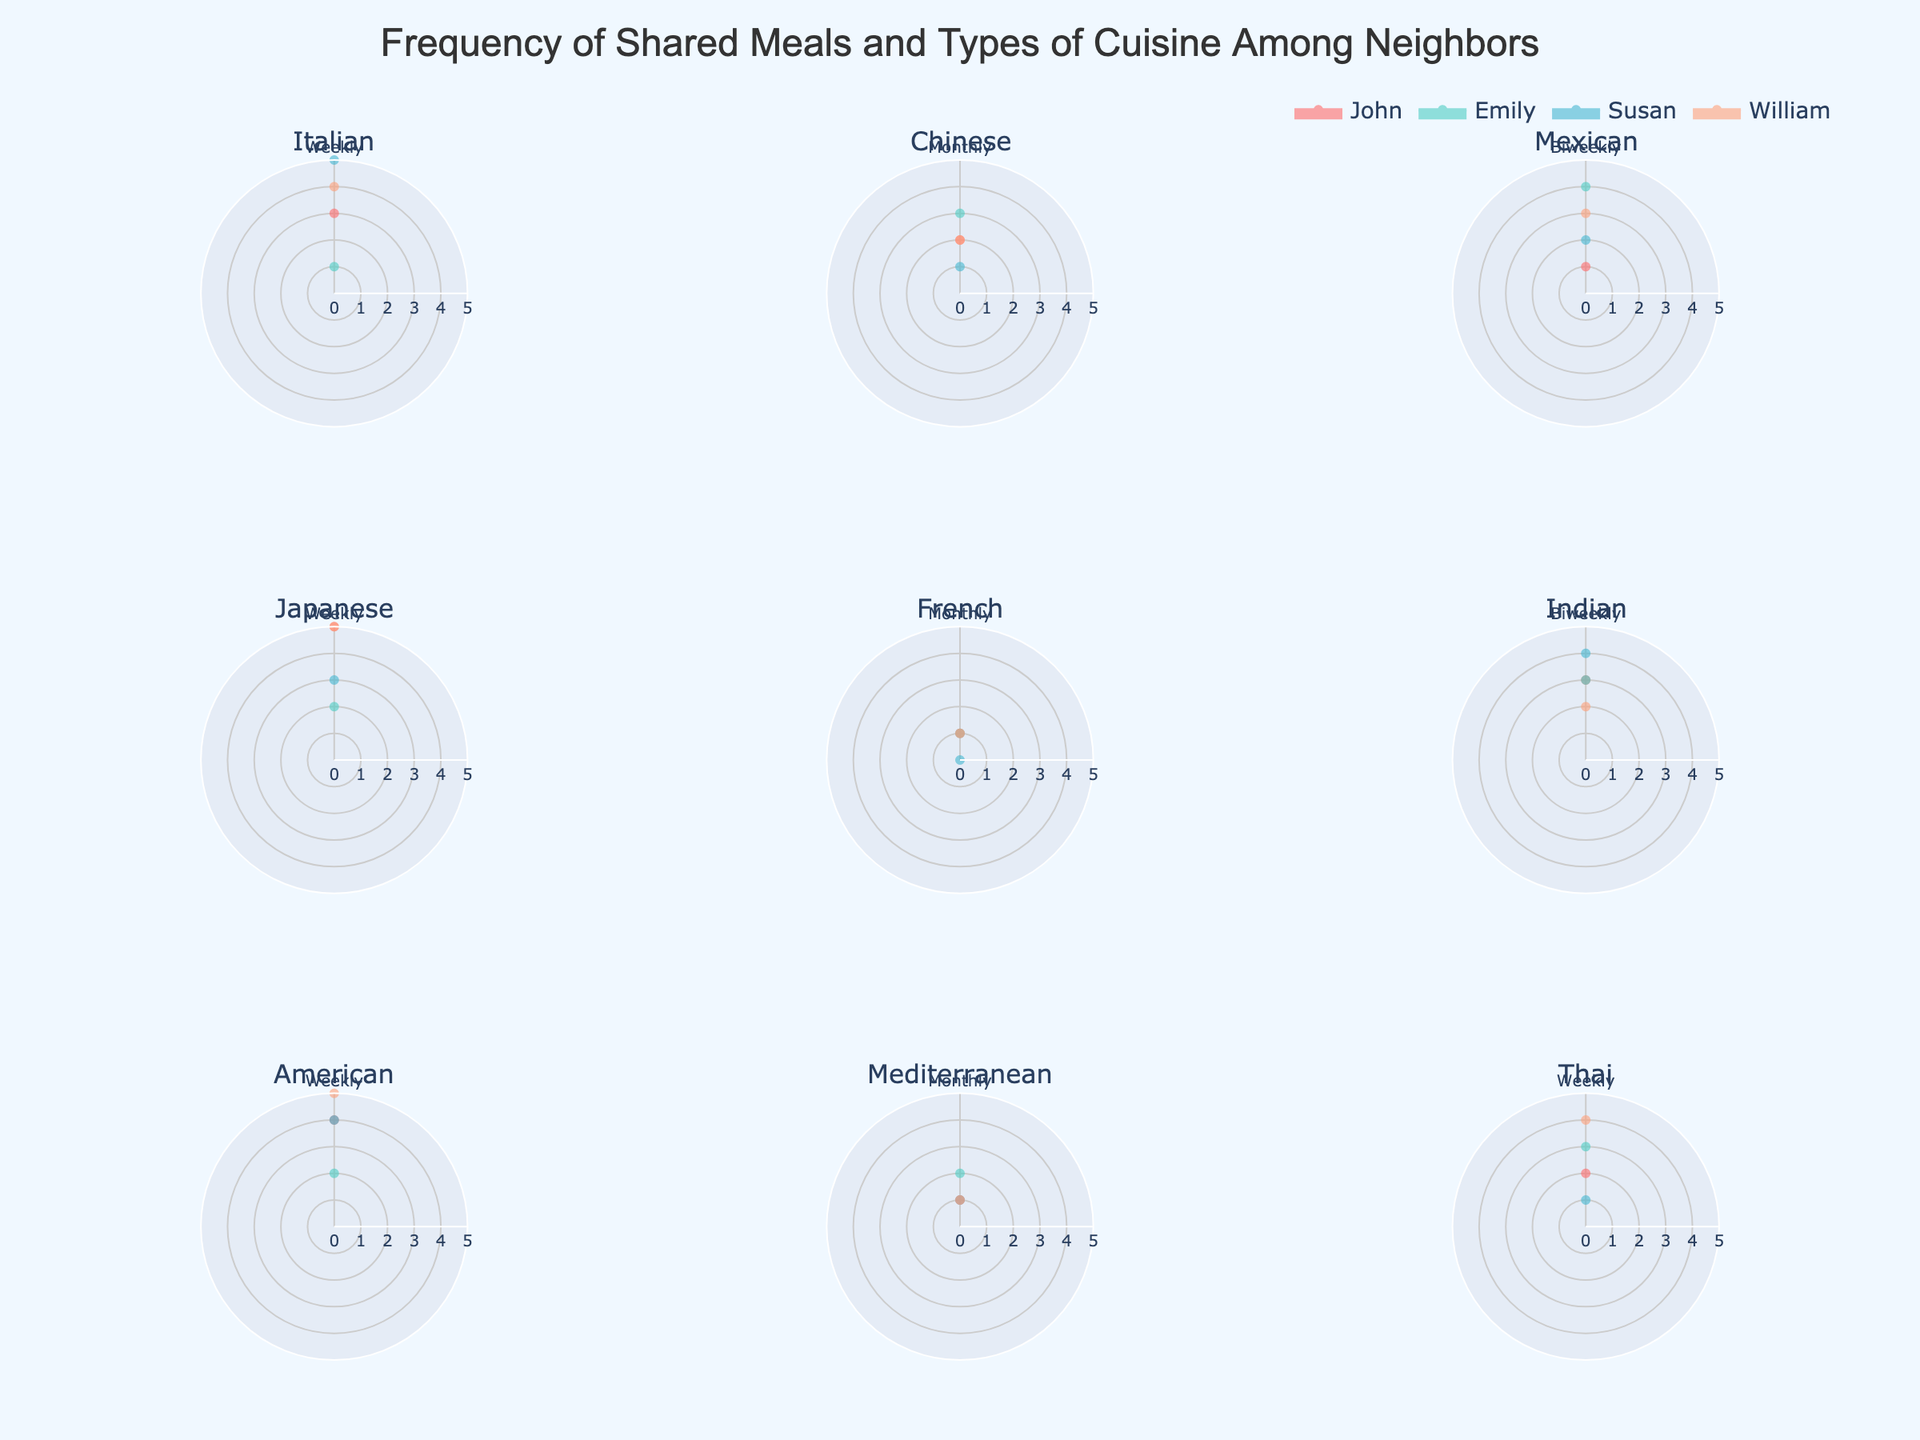Which neighbor eats Japanese food the most frequently on a weekly basis? By looking at the subplot for Japanese cuisine, we can count the radar points at the 'Weekly' angle for each neighbor. William has the highest value of 5.
Answer: William Which cuisine type does John share most often on a weekly basis? Look at John's radar points at the 'Weekly' angle across all cuisine subplots. The highest value is for Japanese food with 5 meals.
Answer: Japanese How many biweekly Mexican meals does Susan share? In the Mexican cuisine subplot, locate Susan's radar points at the 'Biweekly' angle. The value is 2.
Answer: 2 Which cuisine types do William and John have in common on a weekly basis? Check William and John's radar points at the 'Weekly' angle across all cuisine subplots. Both have high values for Japanese and American cuisines.
Answer: Japanese, American Who shares the least number of monthly Mediterranean meals? Locate the Mediterranean cuisine subplot, then look at the 'Monthly' radar points for all neighbors. Susan has the lowest value of 1.
Answer: Susan What is the average number of biweekly Indian meals among all neighbors? In the Indian cuisine subplot, add the values for all neighbors at 'Biweekly' and divide by the number of neighbors (3 + 3 + 4 + 2 = 12, 12 / 4 = 3).
Answer: 3 Compare the number of Chinese meals William and Susan share monthly. Who shares more? Check the Chinese Cuisine subplot under 'Monthly' for both William and Susan. William shares 2 meals, Susan shares 1 meal. William shares more.
Answer: William Which cuisine does Emily eat most frequently? Scan through all subplots to find the highest peak for Emily. The highest is 4 for biweekly Mexican meals.
Answer: Mexican How many U.S. neighbors share American food weekly? In the American cuisine subplot, look at the 'Weekly' points. All four neighbors share American food weekly with values greater than zero.
Answer: 4 What is the most frequent meal frequency for Thai cuisine among all neighbors? Check the Thai cuisine subplot to see the highest values across meal frequencies. The 'Weekly' frequency has the most radar points (William, John, Emily)
Answer: Weekly 